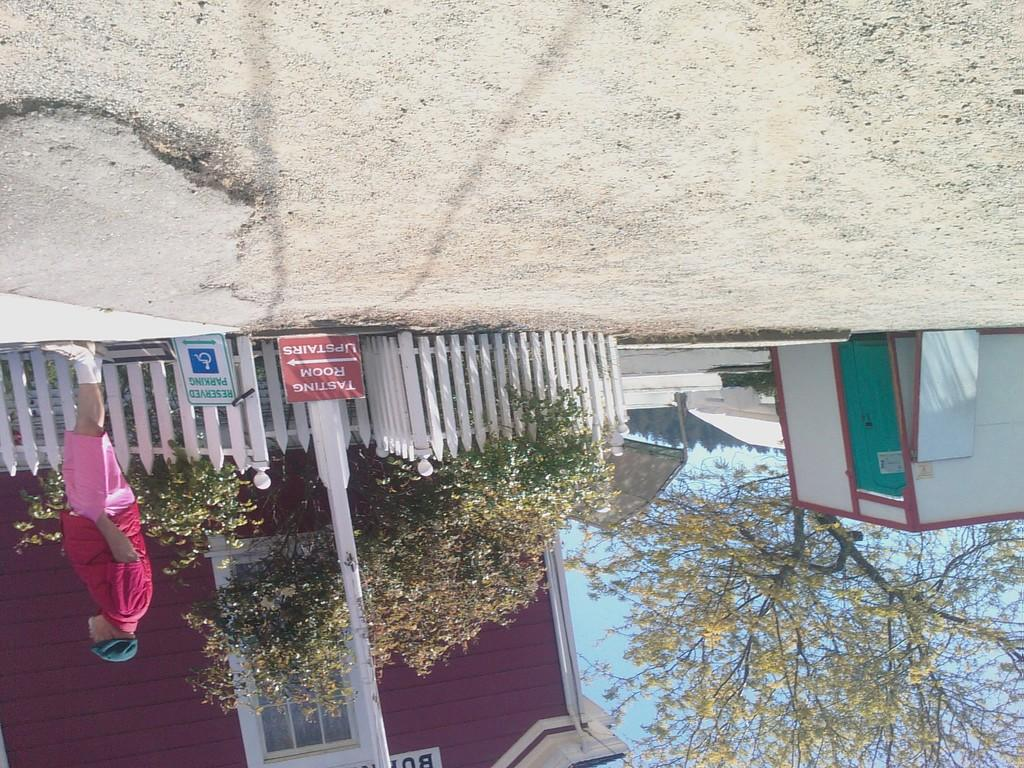What is the orientation of the image? The image appears to be reversed. What type of natural elements can be seen in the image? There are trees visible in the image. Can you describe the person in the image? There is a person standing in the image. What type of objects have text written on them in the image? There are boards with text written on them in the image. What type of straw is being used to smash the boards in the image? There is no straw present in the image, nor is anyone smashing the boards. 